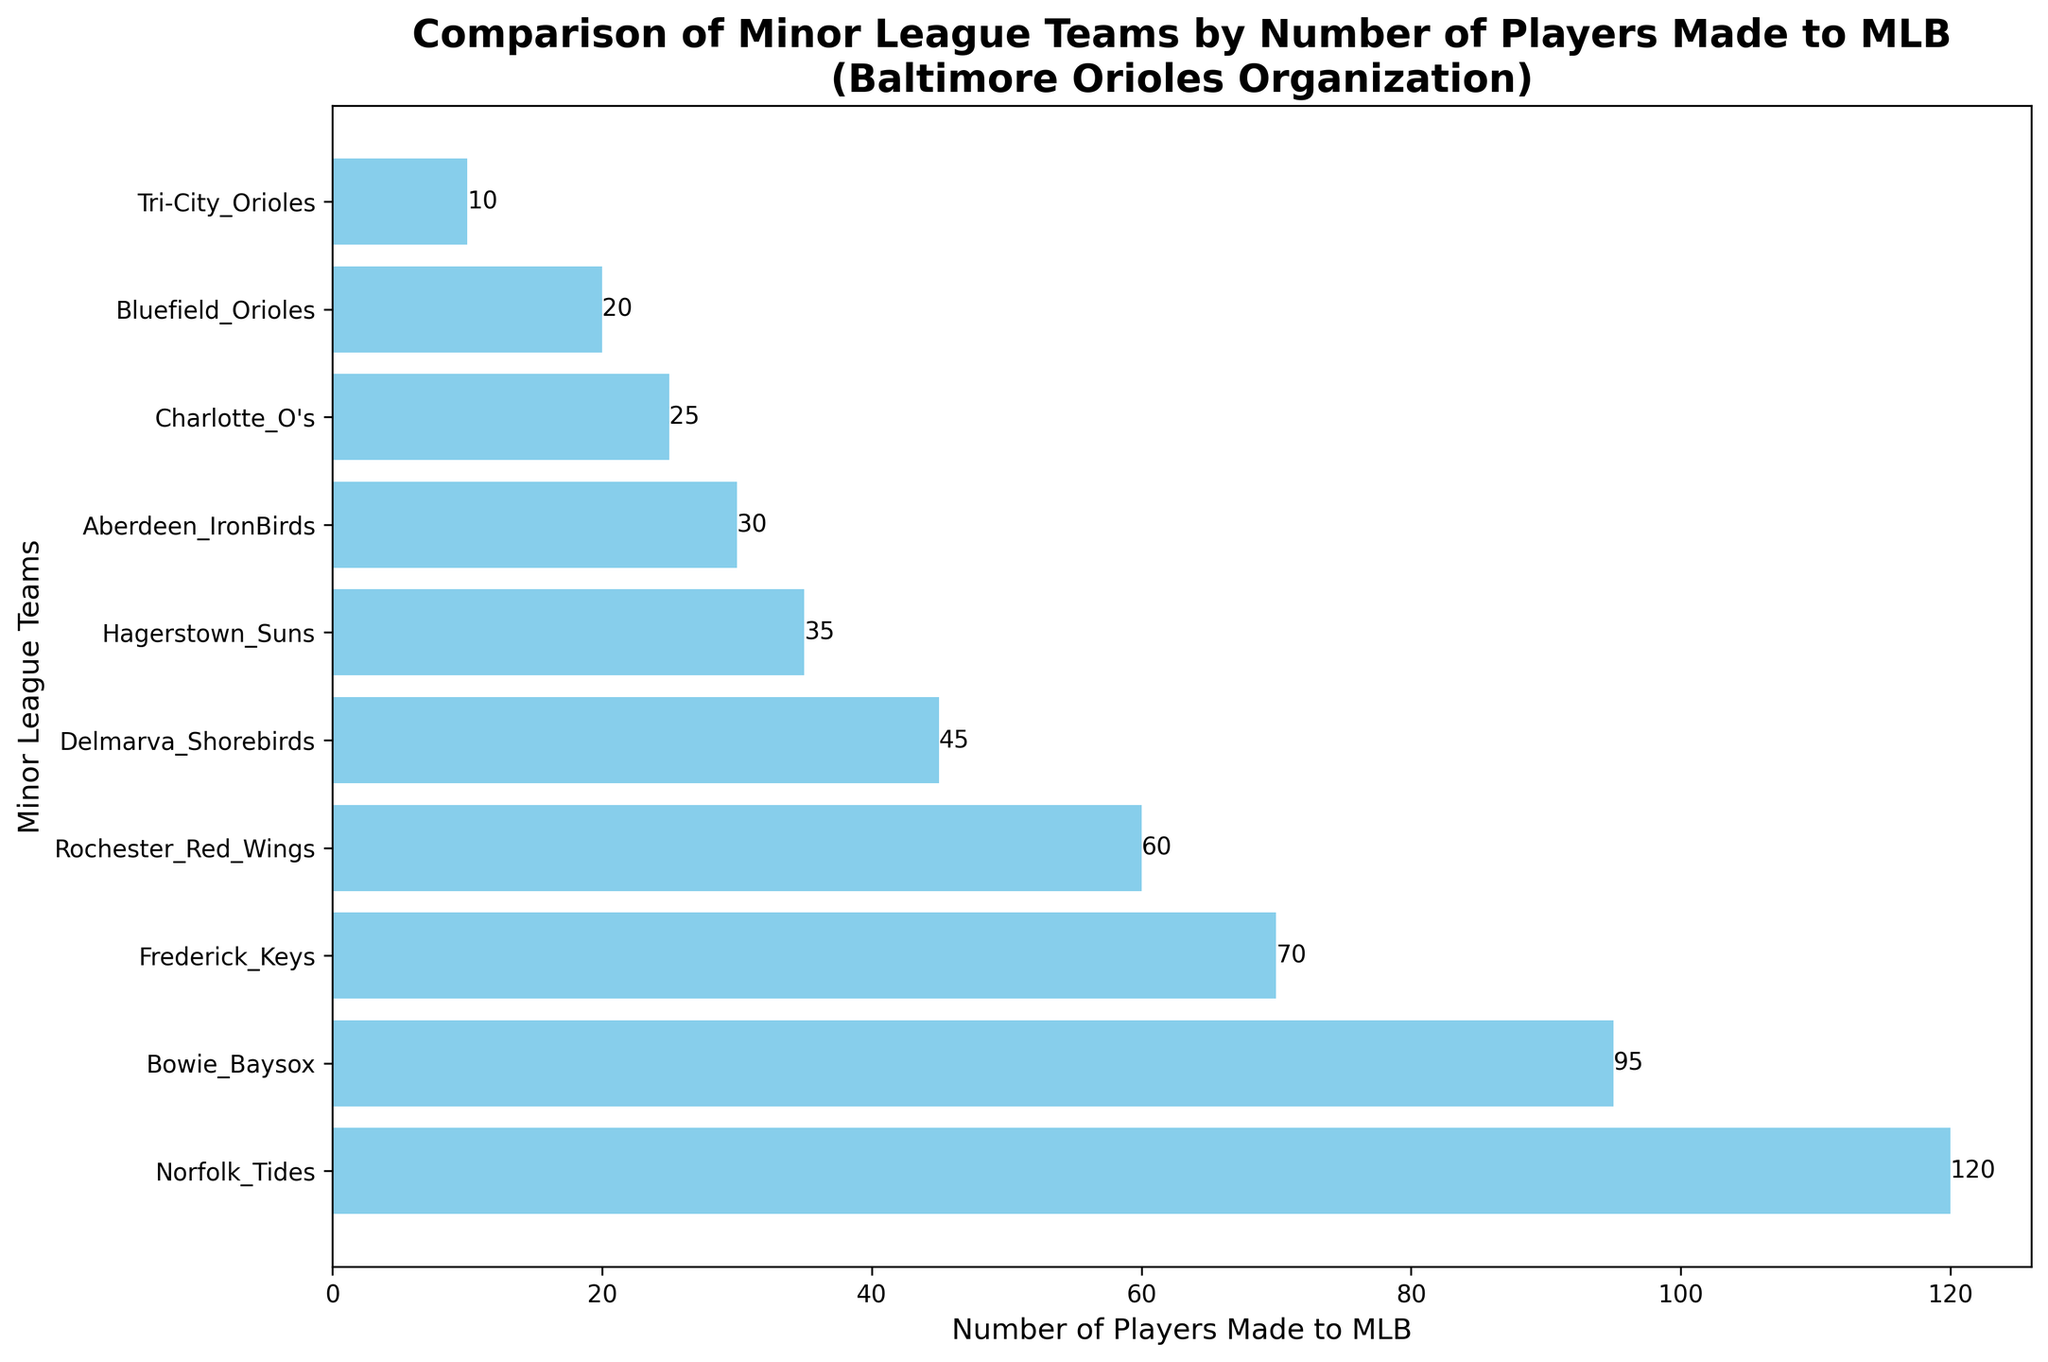What is the total number of players who made it to the MLB from the Norfolk Tides and Bowie Baysox? To find the total, add the number of players from the Norfolk Tides (120) and the Bowie Baysox (95). This gives us 120 + 95 = 215.
Answer: 215 Which team has the fewest number of players who made it to the MLB, and how many players are there? The team with the fewest number of players is the Tri-City Orioles with 10 players.
Answer: Tri-City Orioles, 10 How many more players made it to the MLB from the Frederick Keys than from the Hagerstown Suns? Subtract the number of players from the Hagerstown Suns (35) from the number of players from the Frederick Keys (70). This gives us 70 - 35 = 35.
Answer: 35 What is the average number of players who made it to the MLB across all the listed minor league teams? First, sum the number of players from all the teams: 120 + 95 + 30 + 45 + 70 + 20 + 60 + 35 + 25 + 10 = 510. Then, divide by the number of teams (10): 510 / 10 = 51.
Answer: 51 Which teams have more than 50 players who made it to the MLB, and how many players do they each have? The teams with more than 50 players are Norfolk Tides (120), Bowie Baysox (95), Frederick Keys (70), and Rochester Red Wings (60).
Answer: Norfolk Tides (120), Bowie Baysox (95), Frederick Keys (70), Rochester Red Wings (60) What is the difference in the number of players who made it to the MLB between the team with the most players and the team with the fewest players? Subtract the number of players from the team with the fewest players (Tri-City Orioles, 10) from the team with the most players (Norfolk Tides, 120). This gives us 120 - 10 = 110.
Answer: 110 How does the length of the bar for the Aberdeen IronBirds compare to that of the Delmarva Shorebirds? Aberdeen IronBirds have 30 players and Delmarva Shorebirds have 45 players. Therefore, the bar for Delmarva Shorebirds is longer, as 45 is greater than 30.
Answer: Delmarva Shorebirds' bar is longer Which minor league teams have fewer than 40 players who made it to the MLB, and how many players do they each have? The teams with fewer than 40 players are Aberdeen IronBirds (30), Bluefield Orioles (20), Hagerstown Suns (35), Charlotte O's (25), and Tri-City Orioles (10).
Answer: Aberdeen IronBirds (30), Bluefield Orioles (20), Hagerstown Suns (35), Charlotte O's (25), Tri-City Orioles (10) What is the median number of players who made it to MLB across all the minor league teams? First, list the number of players for each team in ascending order: [10, 20, 25, 30, 35, 45, 60, 70, 95, 120]. The median is the average of the 5th and 6th values because there are an even number of data points. So, (35 + 45) / 2 = 40.
Answer: 40 